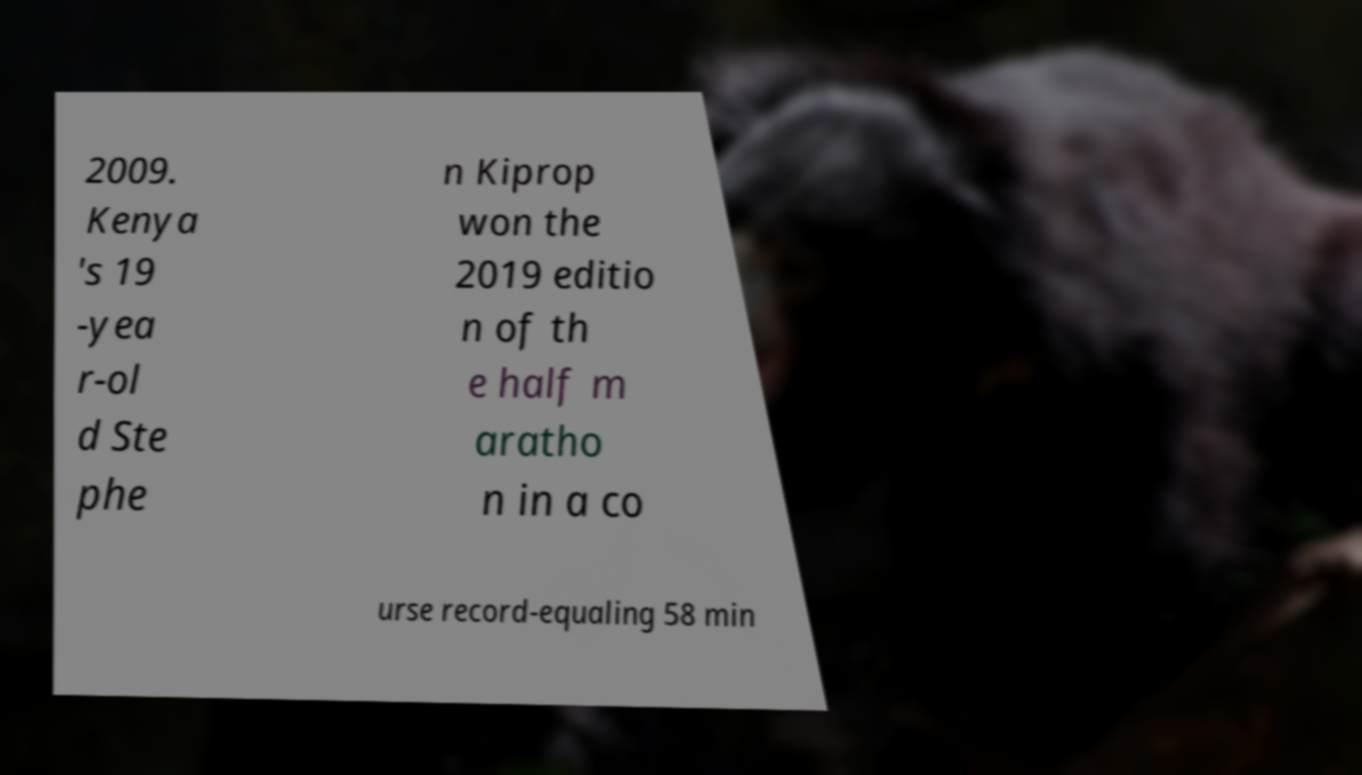What messages or text are displayed in this image? I need them in a readable, typed format. 2009. Kenya 's 19 -yea r-ol d Ste phe n Kiprop won the 2019 editio n of th e half m aratho n in a co urse record-equaling 58 min 